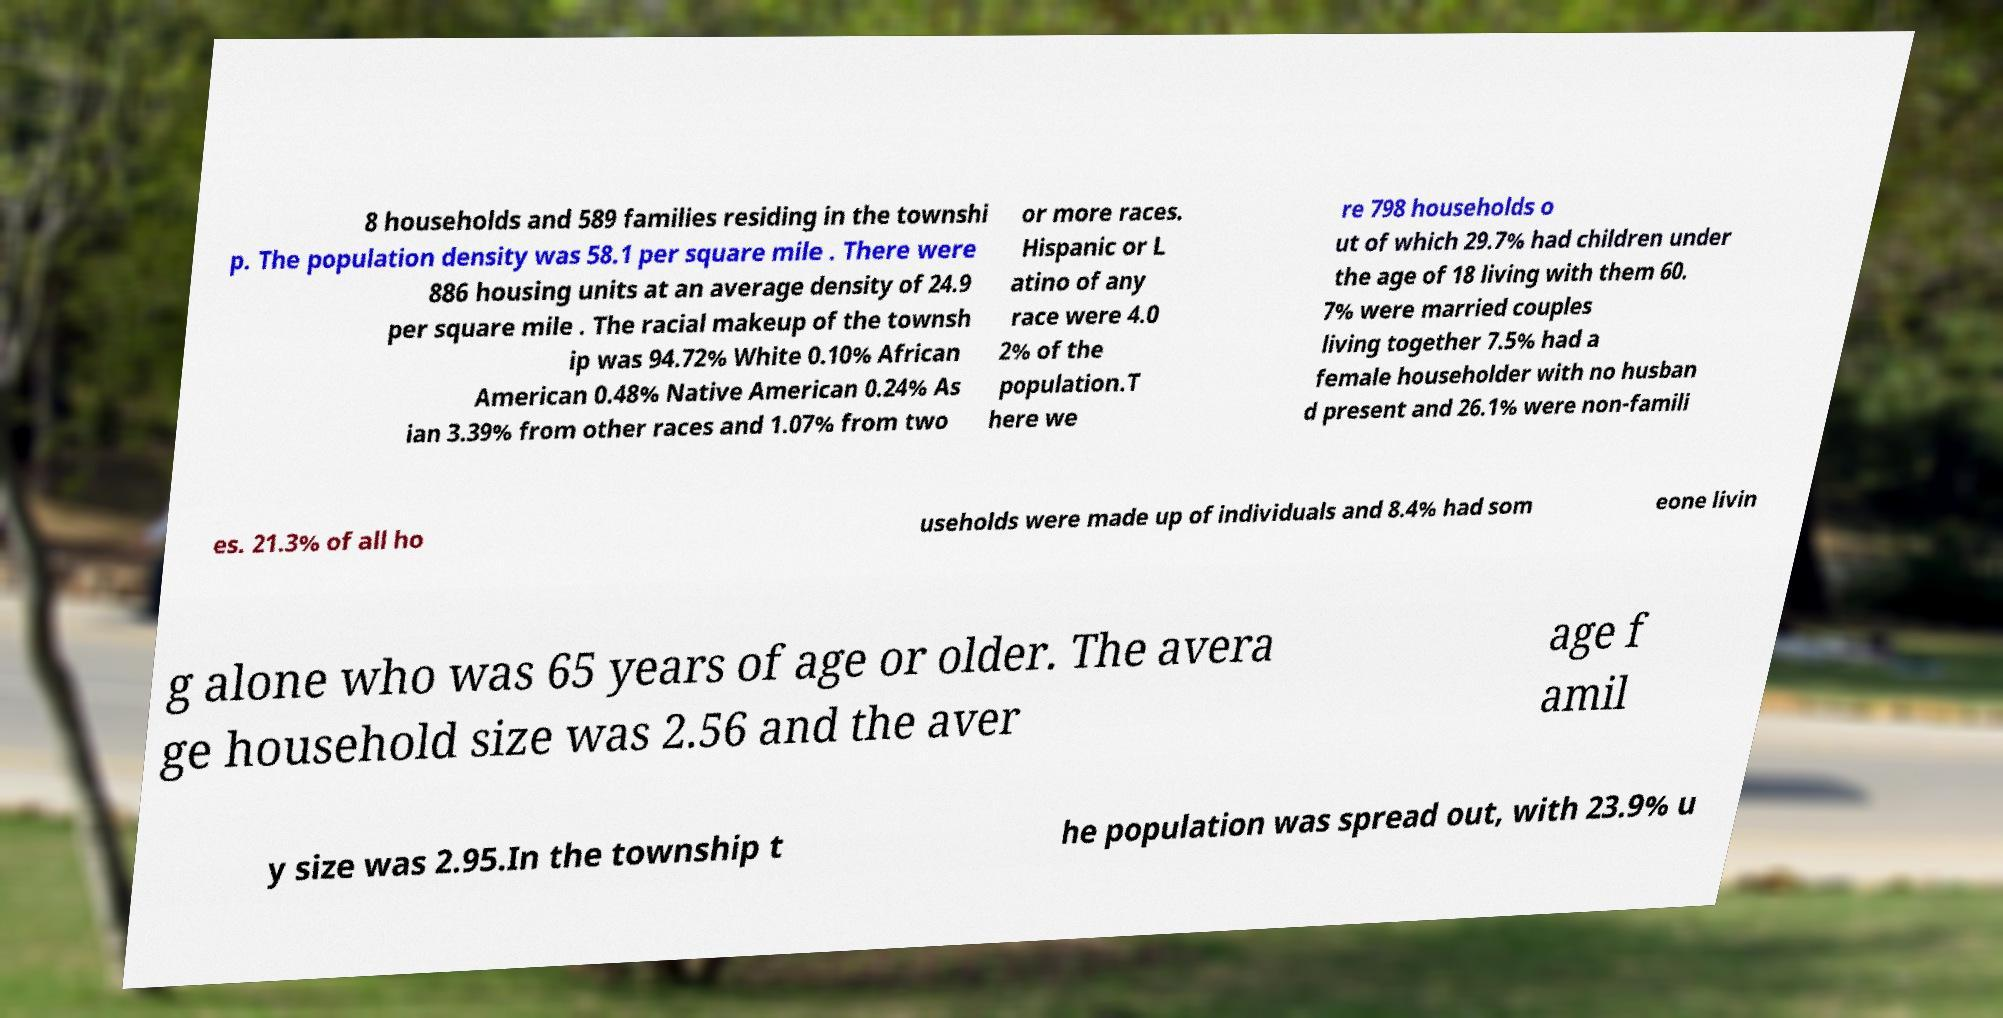Can you accurately transcribe the text from the provided image for me? 8 households and 589 families residing in the townshi p. The population density was 58.1 per square mile . There were 886 housing units at an average density of 24.9 per square mile . The racial makeup of the townsh ip was 94.72% White 0.10% African American 0.48% Native American 0.24% As ian 3.39% from other races and 1.07% from two or more races. Hispanic or L atino of any race were 4.0 2% of the population.T here we re 798 households o ut of which 29.7% had children under the age of 18 living with them 60. 7% were married couples living together 7.5% had a female householder with no husban d present and 26.1% were non-famili es. 21.3% of all ho useholds were made up of individuals and 8.4% had som eone livin g alone who was 65 years of age or older. The avera ge household size was 2.56 and the aver age f amil y size was 2.95.In the township t he population was spread out, with 23.9% u 